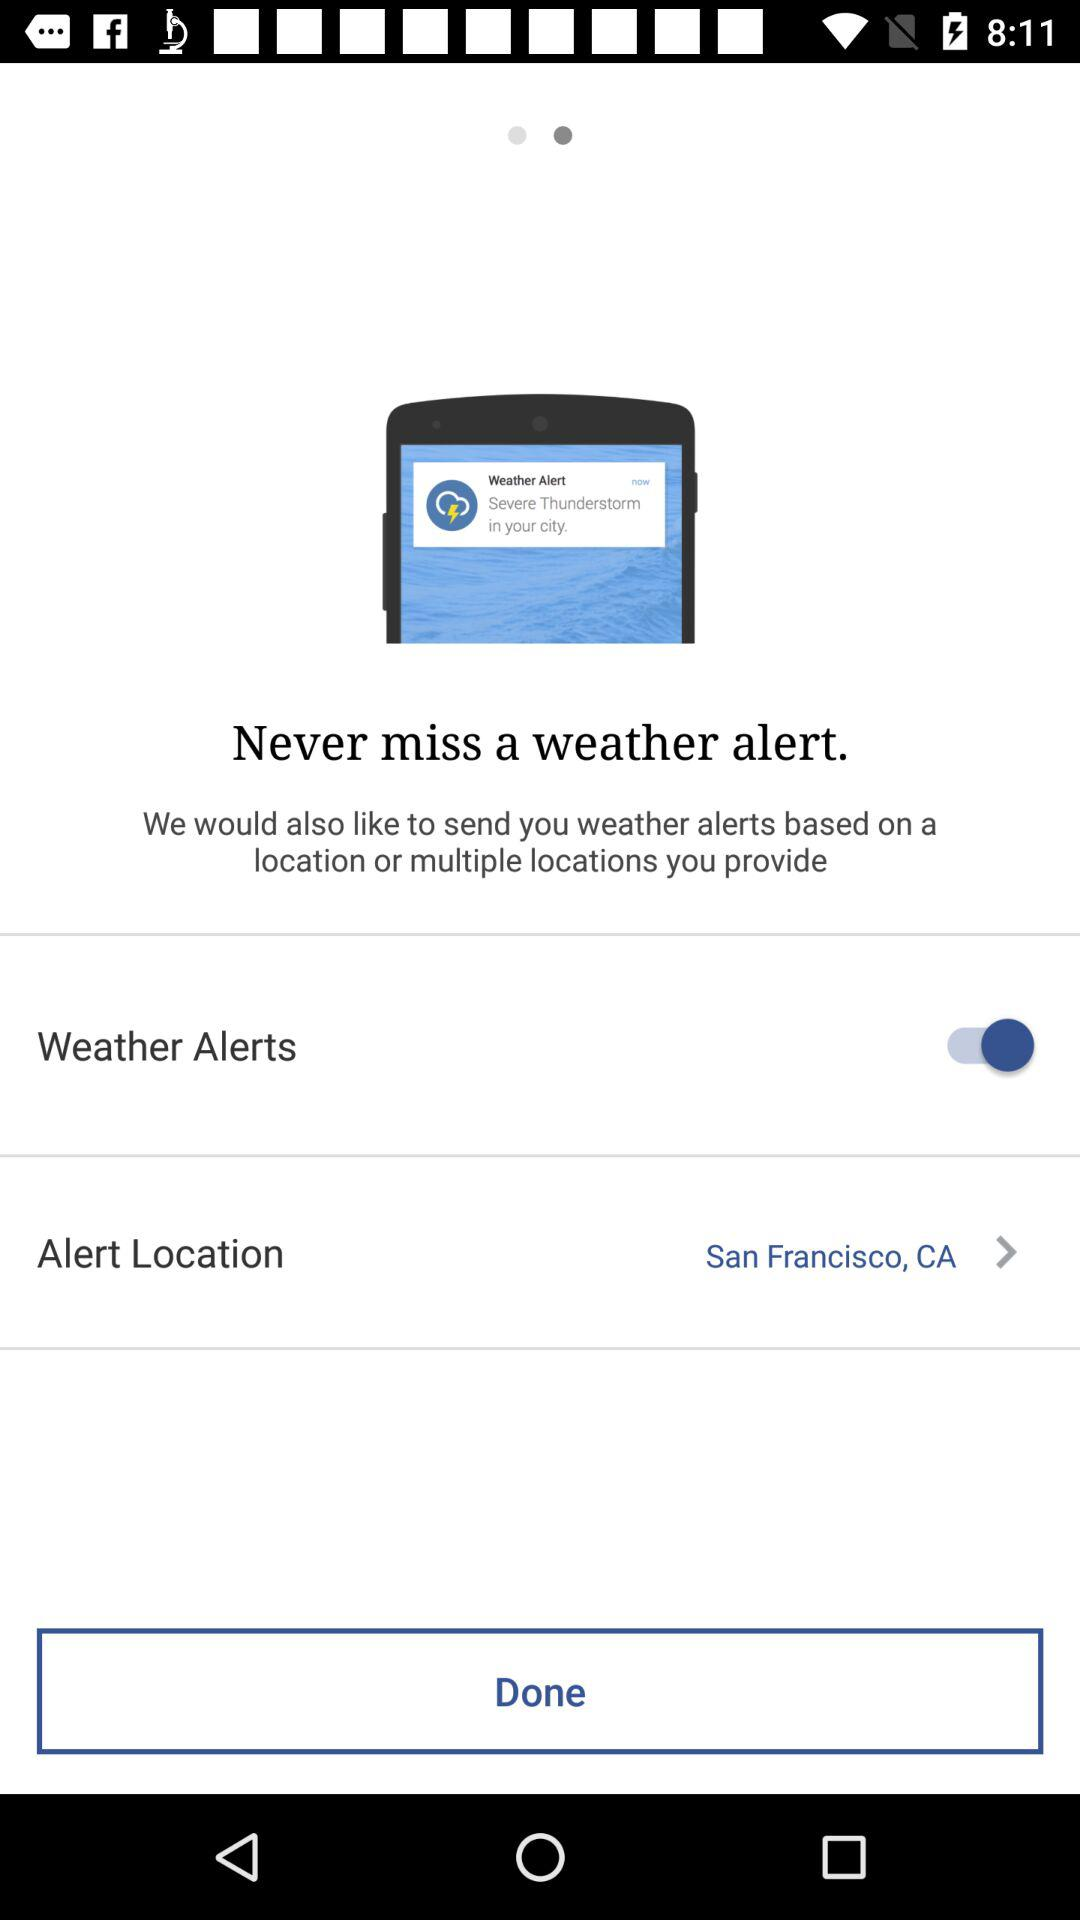What is the status of the "Weather Alerts"? The status is "on". 